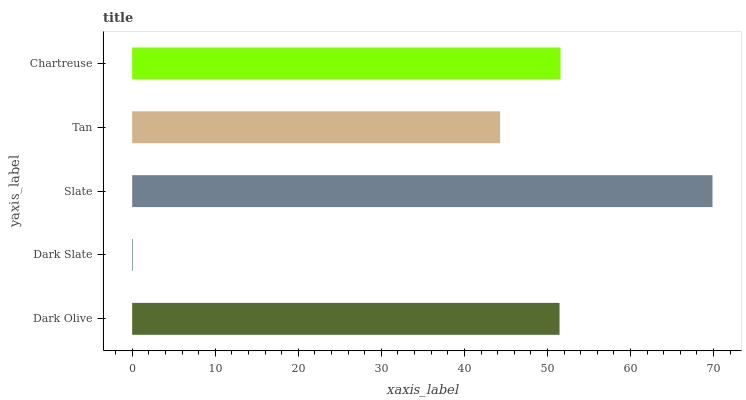Is Dark Slate the minimum?
Answer yes or no. Yes. Is Slate the maximum?
Answer yes or no. Yes. Is Slate the minimum?
Answer yes or no. No. Is Dark Slate the maximum?
Answer yes or no. No. Is Slate greater than Dark Slate?
Answer yes or no. Yes. Is Dark Slate less than Slate?
Answer yes or no. Yes. Is Dark Slate greater than Slate?
Answer yes or no. No. Is Slate less than Dark Slate?
Answer yes or no. No. Is Dark Olive the high median?
Answer yes or no. Yes. Is Dark Olive the low median?
Answer yes or no. Yes. Is Dark Slate the high median?
Answer yes or no. No. Is Tan the low median?
Answer yes or no. No. 